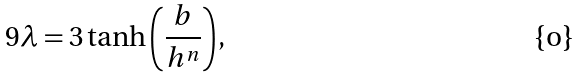<formula> <loc_0><loc_0><loc_500><loc_500>9 \lambda = 3 \tanh { \left ( \frac { b } { h ^ { n } } \right ) } ,</formula> 